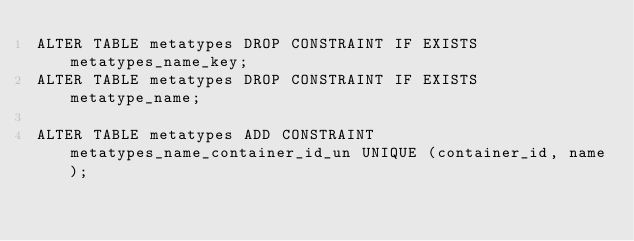<code> <loc_0><loc_0><loc_500><loc_500><_SQL_>ALTER TABLE metatypes DROP CONSTRAINT IF EXISTS metatypes_name_key;
ALTER TABLE metatypes DROP CONSTRAINT IF EXISTS metatype_name;

ALTER TABLE metatypes ADD CONSTRAINT metatypes_name_container_id_un UNIQUE (container_id, name);
</code> 